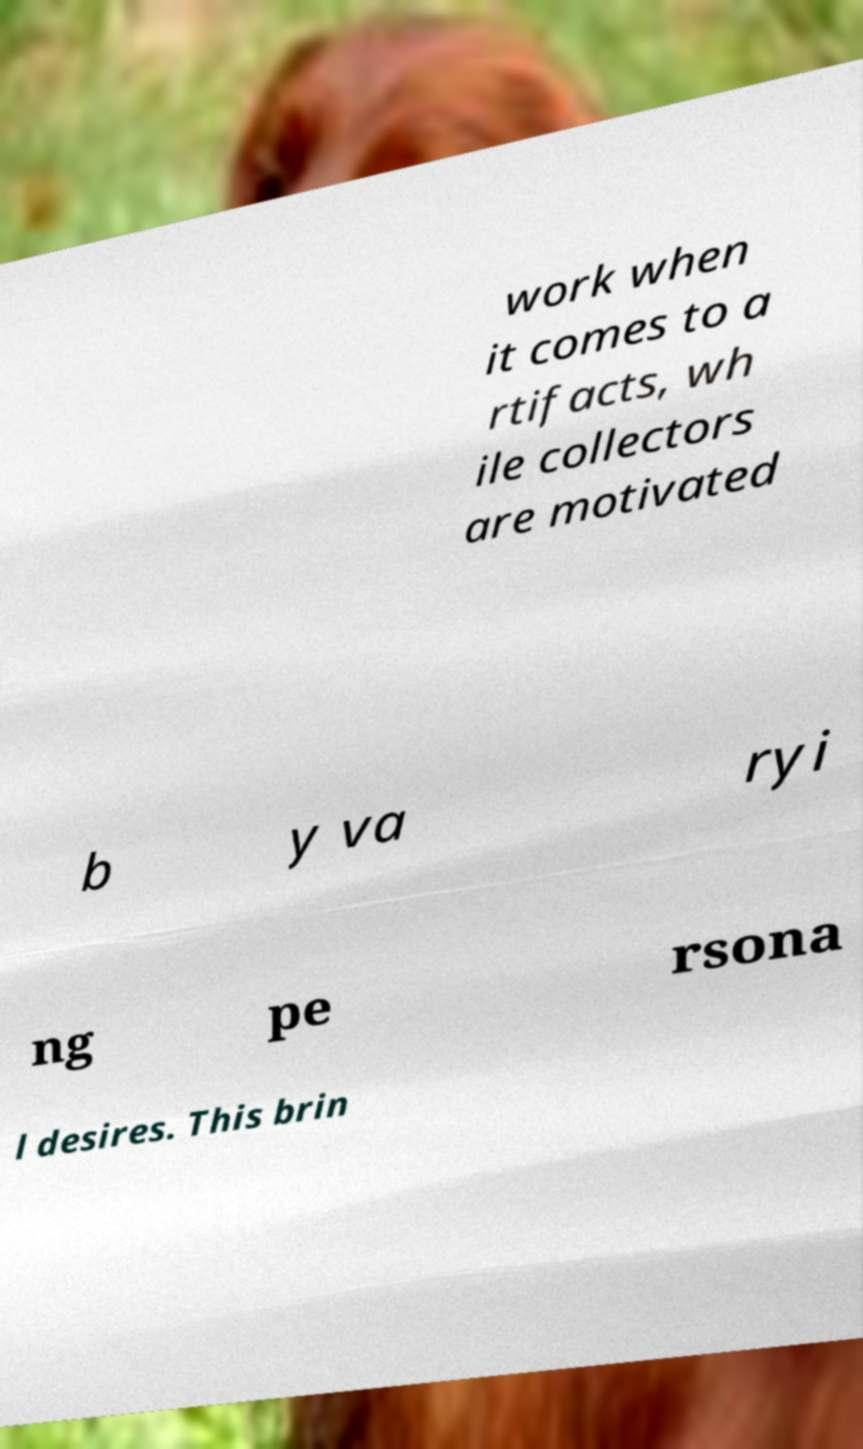Could you extract and type out the text from this image? work when it comes to a rtifacts, wh ile collectors are motivated b y va ryi ng pe rsona l desires. This brin 